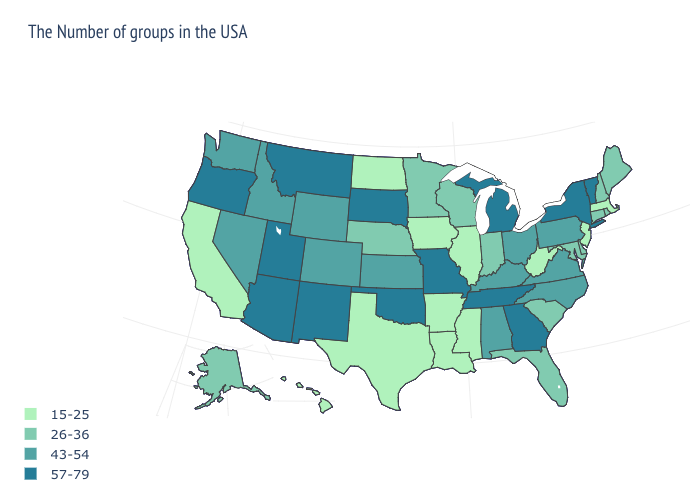What is the value of Rhode Island?
Write a very short answer. 26-36. What is the value of North Dakota?
Write a very short answer. 15-25. What is the lowest value in the USA?
Concise answer only. 15-25. Name the states that have a value in the range 15-25?
Give a very brief answer. Massachusetts, New Jersey, West Virginia, Illinois, Mississippi, Louisiana, Arkansas, Iowa, Texas, North Dakota, California, Hawaii. Name the states that have a value in the range 43-54?
Write a very short answer. Pennsylvania, Virginia, North Carolina, Ohio, Kentucky, Alabama, Kansas, Wyoming, Colorado, Idaho, Nevada, Washington. Among the states that border North Carolina , does Georgia have the lowest value?
Concise answer only. No. Does Oklahoma have the highest value in the USA?
Give a very brief answer. Yes. Name the states that have a value in the range 43-54?
Quick response, please. Pennsylvania, Virginia, North Carolina, Ohio, Kentucky, Alabama, Kansas, Wyoming, Colorado, Idaho, Nevada, Washington. What is the highest value in states that border North Carolina?
Keep it brief. 57-79. Name the states that have a value in the range 15-25?
Quick response, please. Massachusetts, New Jersey, West Virginia, Illinois, Mississippi, Louisiana, Arkansas, Iowa, Texas, North Dakota, California, Hawaii. Is the legend a continuous bar?
Be succinct. No. What is the value of Wyoming?
Write a very short answer. 43-54. Name the states that have a value in the range 57-79?
Be succinct. Vermont, New York, Georgia, Michigan, Tennessee, Missouri, Oklahoma, South Dakota, New Mexico, Utah, Montana, Arizona, Oregon. Name the states that have a value in the range 57-79?
Quick response, please. Vermont, New York, Georgia, Michigan, Tennessee, Missouri, Oklahoma, South Dakota, New Mexico, Utah, Montana, Arizona, Oregon. Does Pennsylvania have the highest value in the Northeast?
Short answer required. No. 